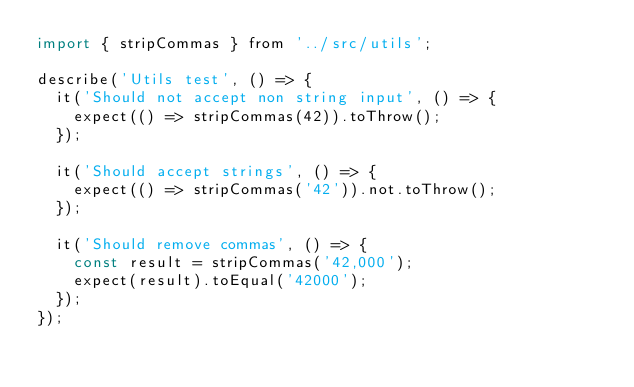Convert code to text. <code><loc_0><loc_0><loc_500><loc_500><_JavaScript_>import { stripCommas } from '../src/utils';

describe('Utils test', () => {
  it('Should not accept non string input', () => {
    expect(() => stripCommas(42)).toThrow();
  });

  it('Should accept strings', () => {
    expect(() => stripCommas('42')).not.toThrow();
  });

  it('Should remove commas', () => {
    const result = stripCommas('42,000');
    expect(result).toEqual('42000');
  });
});
</code> 